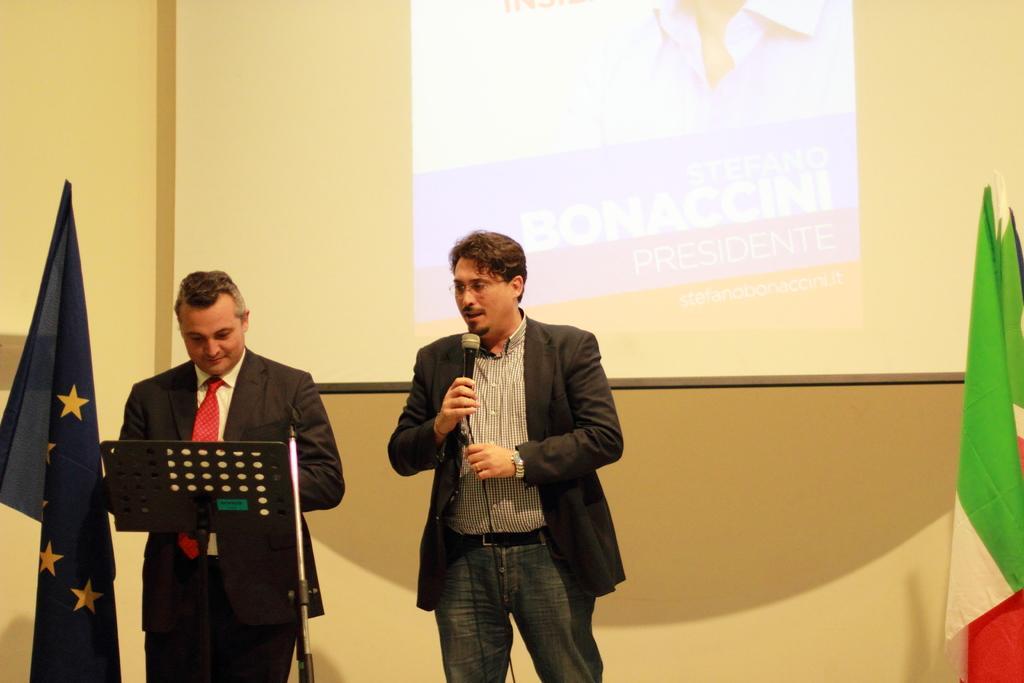Can you describe this image briefly? This is the picture of two people wearing black suit and standing among them one is holding the mike and behind the screen and two flags beside them. 